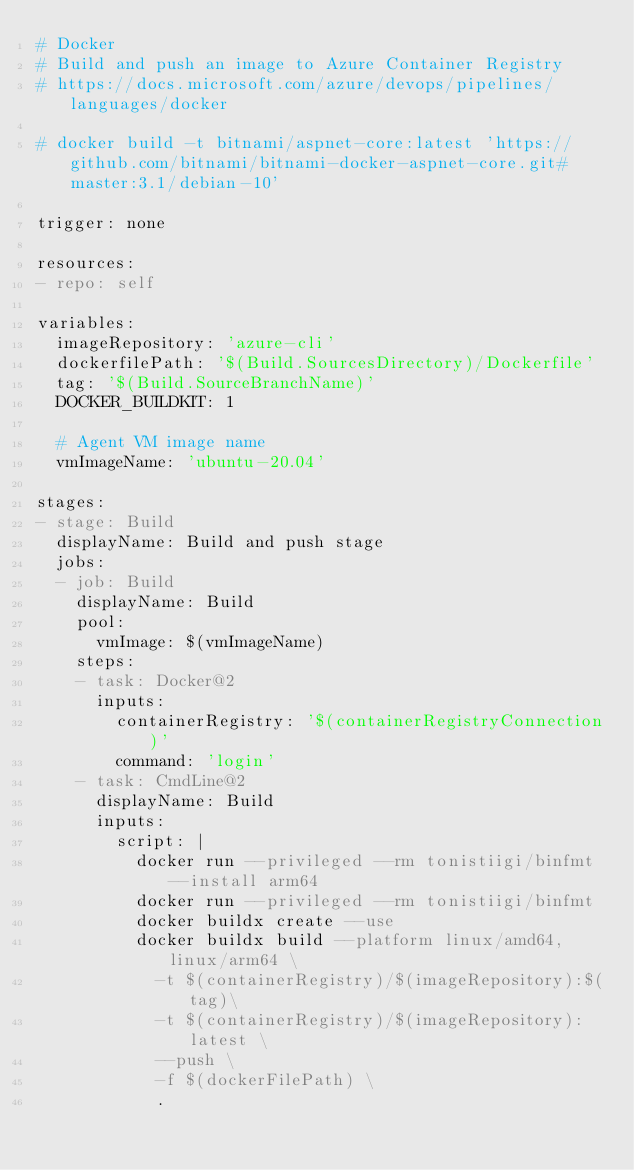<code> <loc_0><loc_0><loc_500><loc_500><_YAML_># Docker
# Build and push an image to Azure Container Registry
# https://docs.microsoft.com/azure/devops/pipelines/languages/docker

# docker build -t bitnami/aspnet-core:latest 'https://github.com/bitnami/bitnami-docker-aspnet-core.git#master:3.1/debian-10'

trigger: none

resources:
- repo: self

variables:
  imageRepository: 'azure-cli'
  dockerfilePath: '$(Build.SourcesDirectory)/Dockerfile'
  tag: '$(Build.SourceBranchName)'
  DOCKER_BUILDKIT: 1

  # Agent VM image name
  vmImageName: 'ubuntu-20.04'

stages:
- stage: Build
  displayName: Build and push stage
  jobs:
  - job: Build
    displayName: Build
    pool:
      vmImage: $(vmImageName)
    steps:
    - task: Docker@2
      inputs:
        containerRegistry: '$(containerRegistryConnection)'
        command: 'login'
    - task: CmdLine@2
      displayName: Build
      inputs:
        script: |
          docker run --privileged --rm tonistiigi/binfmt --install arm64
          docker run --privileged --rm tonistiigi/binfmt
          docker buildx create --use
          docker buildx build --platform linux/amd64,linux/arm64 \
            -t $(containerRegistry)/$(imageRepository):$(tag)\
            -t $(containerRegistry)/$(imageRepository):latest \
            --push \
            -f $(dockerFilePath) \
            .</code> 